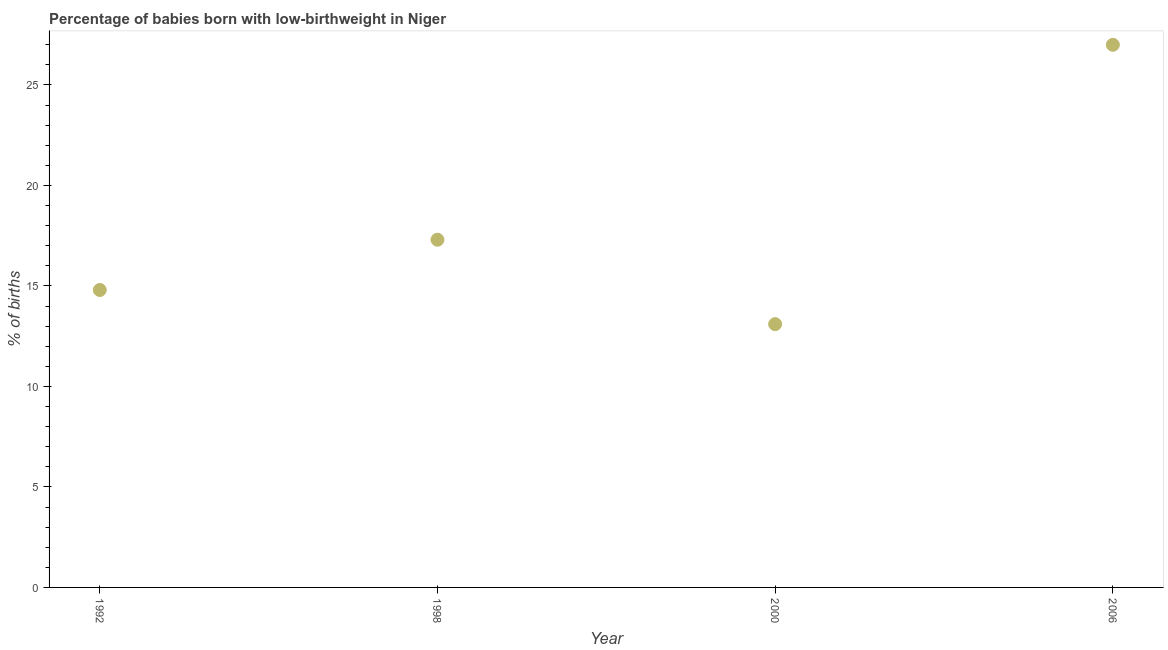In which year was the percentage of babies who were born with low-birthweight maximum?
Give a very brief answer. 2006. In which year was the percentage of babies who were born with low-birthweight minimum?
Your answer should be compact. 2000. What is the sum of the percentage of babies who were born with low-birthweight?
Offer a terse response. 72.2. What is the difference between the percentage of babies who were born with low-birthweight in 1998 and 2000?
Provide a succinct answer. 4.2. What is the average percentage of babies who were born with low-birthweight per year?
Offer a very short reply. 18.05. What is the median percentage of babies who were born with low-birthweight?
Provide a succinct answer. 16.05. In how many years, is the percentage of babies who were born with low-birthweight greater than 1 %?
Your response must be concise. 4. Do a majority of the years between 1992 and 2006 (inclusive) have percentage of babies who were born with low-birthweight greater than 8 %?
Offer a very short reply. Yes. What is the ratio of the percentage of babies who were born with low-birthweight in 1998 to that in 2006?
Offer a very short reply. 0.64. What is the difference between the highest and the second highest percentage of babies who were born with low-birthweight?
Keep it short and to the point. 9.7. What is the difference between the highest and the lowest percentage of babies who were born with low-birthweight?
Keep it short and to the point. 13.9. How many dotlines are there?
Keep it short and to the point. 1. What is the title of the graph?
Make the answer very short. Percentage of babies born with low-birthweight in Niger. What is the label or title of the X-axis?
Make the answer very short. Year. What is the label or title of the Y-axis?
Your response must be concise. % of births. What is the % of births in 1998?
Your response must be concise. 17.3. What is the difference between the % of births in 1992 and 1998?
Give a very brief answer. -2.5. What is the difference between the % of births in 1992 and 2000?
Provide a succinct answer. 1.7. What is the difference between the % of births in 1998 and 2000?
Keep it short and to the point. 4.2. What is the difference between the % of births in 1998 and 2006?
Offer a terse response. -9.7. What is the difference between the % of births in 2000 and 2006?
Ensure brevity in your answer.  -13.9. What is the ratio of the % of births in 1992 to that in 1998?
Your answer should be compact. 0.85. What is the ratio of the % of births in 1992 to that in 2000?
Your answer should be compact. 1.13. What is the ratio of the % of births in 1992 to that in 2006?
Provide a short and direct response. 0.55. What is the ratio of the % of births in 1998 to that in 2000?
Offer a very short reply. 1.32. What is the ratio of the % of births in 1998 to that in 2006?
Give a very brief answer. 0.64. What is the ratio of the % of births in 2000 to that in 2006?
Make the answer very short. 0.48. 